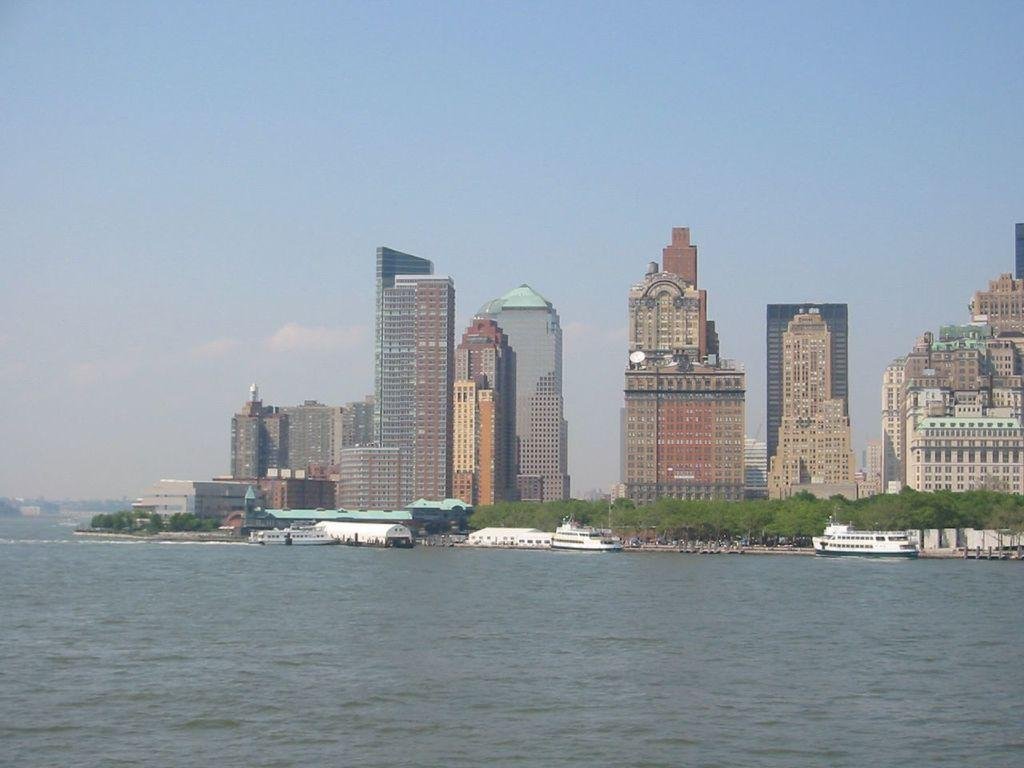What is located in the center of the image? There are buildings in the center of the image. What else can be seen in the image besides the buildings? There are boats and trees visible in the image. What type of surface is visible at the bottom of the image? There is water visible at the bottom of the image. Where is the jar located in the image? There is no jar present in the image. What type of class is being held in the image? There is no class or educational setting depicted in the image. 